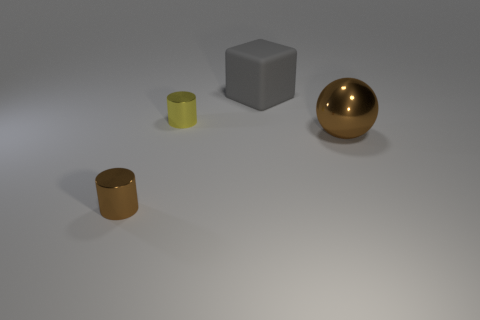There is a brown thing left of the big brown metal sphere; what shape is it?
Ensure brevity in your answer.  Cylinder. What shape is the metallic object that is the same size as the yellow cylinder?
Make the answer very short. Cylinder. There is a large thing in front of the big object that is left of the brown metal object behind the brown shiny cylinder; what is its color?
Make the answer very short. Brown. Does the tiny brown metallic object have the same shape as the yellow shiny object?
Your response must be concise. Yes. Are there an equal number of shiny objects to the right of the big brown sphere and large blue balls?
Make the answer very short. Yes. How many other things are made of the same material as the yellow object?
Your answer should be very brief. 2. Does the cylinder that is behind the metallic ball have the same size as the thing on the right side of the gray block?
Ensure brevity in your answer.  No. What number of objects are metal cylinders that are in front of the brown metal ball or things right of the large rubber thing?
Make the answer very short. 2. Is there any other thing that is the same shape as the gray matte object?
Your response must be concise. No. There is a object that is to the right of the gray matte cube; does it have the same color as the cylinder that is in front of the large brown metallic ball?
Offer a very short reply. Yes. 